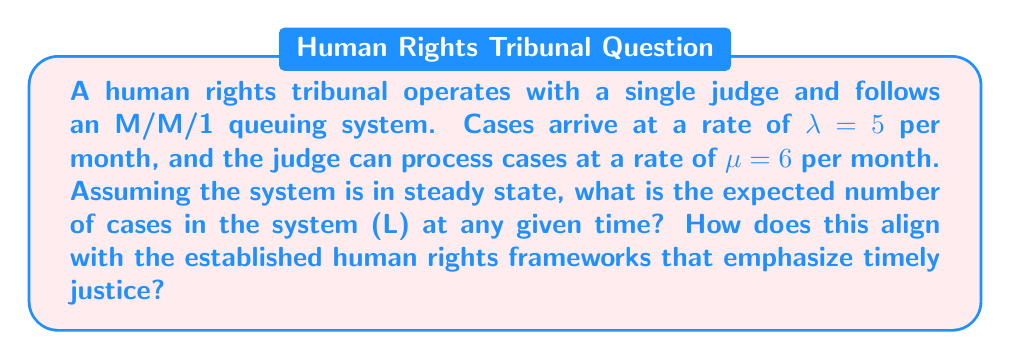Teach me how to tackle this problem. To solve this problem, we'll use the fundamental equations of M/M/1 queuing theory:

1. First, calculate the utilization factor $\rho$:
   $\rho = \frac{\lambda}{\mu} = \frac{5}{6} \approx 0.833$

2. The expected number of cases in the system (L) is given by:
   $L = \frac{\rho}{1-\rho}$

3. Substituting the value of $\rho$:
   $L = \frac{0.833}{1-0.833} = \frac{0.833}{0.167} \approx 4.988$

4. Therefore, the expected number of cases in the system at any given time is approximately 5.

5. Interpretation: This result indicates that, on average, there are about 5 cases in the tribunal system (either being processed or waiting). This relatively high number suggests potential delays in case resolution, which may conflict with established human rights frameworks emphasizing timely justice.

6. The high utilization factor (0.833) also indicates that the judge is working at near capacity, which could lead to burnout and potentially compromise the quality of case reviews.

7. To better align with established human rights frameworks, the tribunal might consider adding more judges or improving case processing efficiency to reduce waiting times and ensure more timely justice.
Answer: $L \approx 5$ cases 